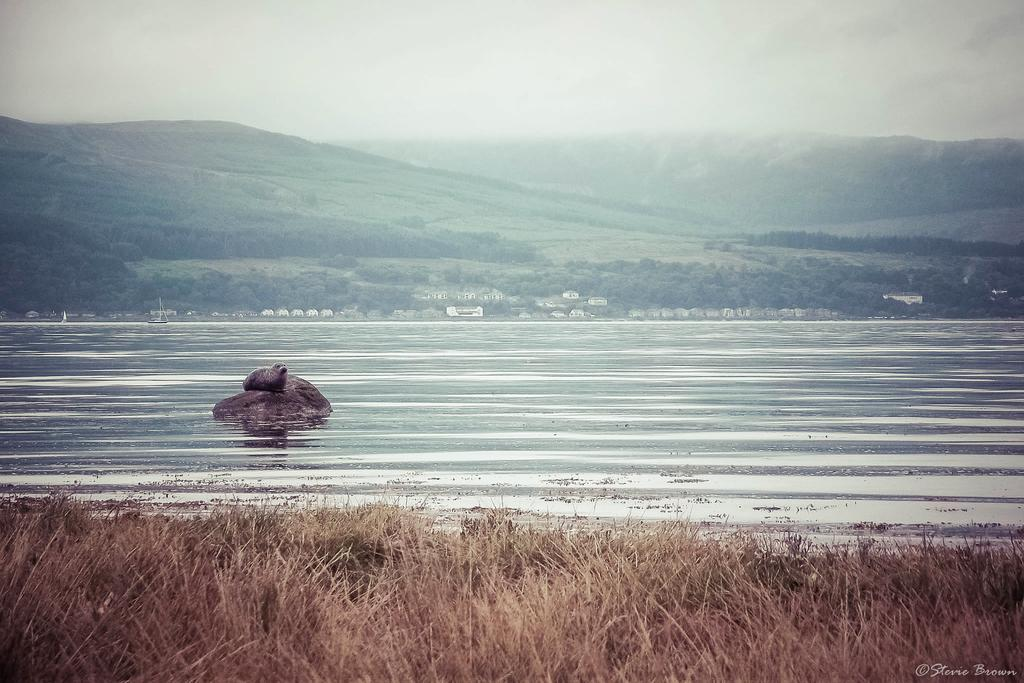What is one of the natural elements present in the image? There is water in the image. What type of vegetation can be seen in the image? There is grass in the image. What other objects can be found in the image? There are stones in the image. What geographical features are visible in the image? There are hills in the image. What else is present in the image besides the natural elements? There are trees in the image. What part of the environment is visible in the image? The sky is visible in the image. How many cherries are hanging from the trees in the image? There are no cherries present in the image; it features trees without any fruit. What type of clock can be seen in the image? There is no clock present in the image. 